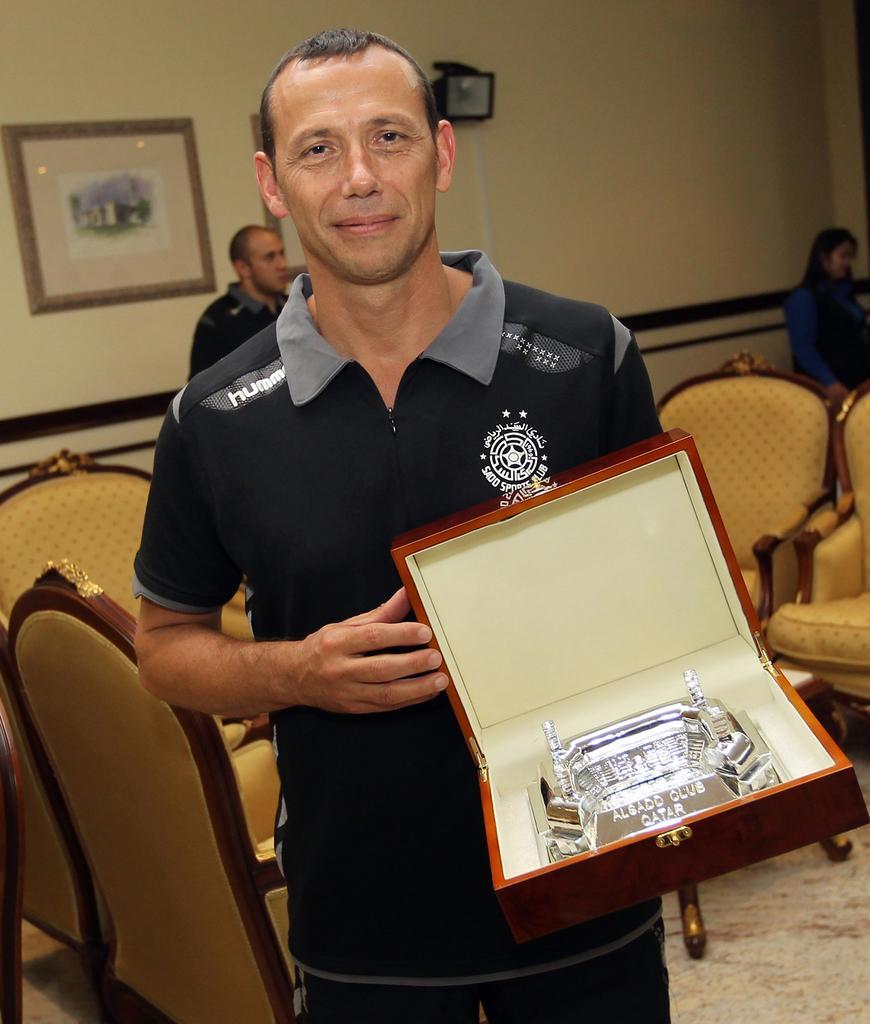Could you give a brief overview of what you see in this image? As we can see in the image there is a wall, photo frame, chairs and the man who is standing here is holding box. 